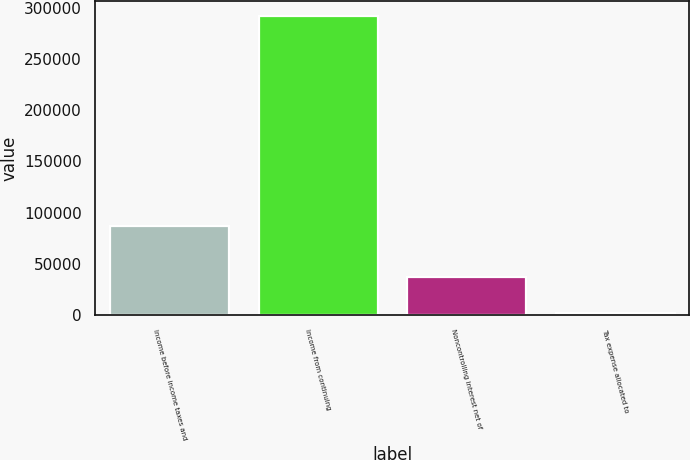Convert chart to OTSL. <chart><loc_0><loc_0><loc_500><loc_500><bar_chart><fcel>Income before income taxes and<fcel>Income from continuing<fcel>Noncontrolling interest net of<fcel>Tax expense allocated to<nl><fcel>87322<fcel>292269<fcel>36961<fcel>1622<nl></chart> 